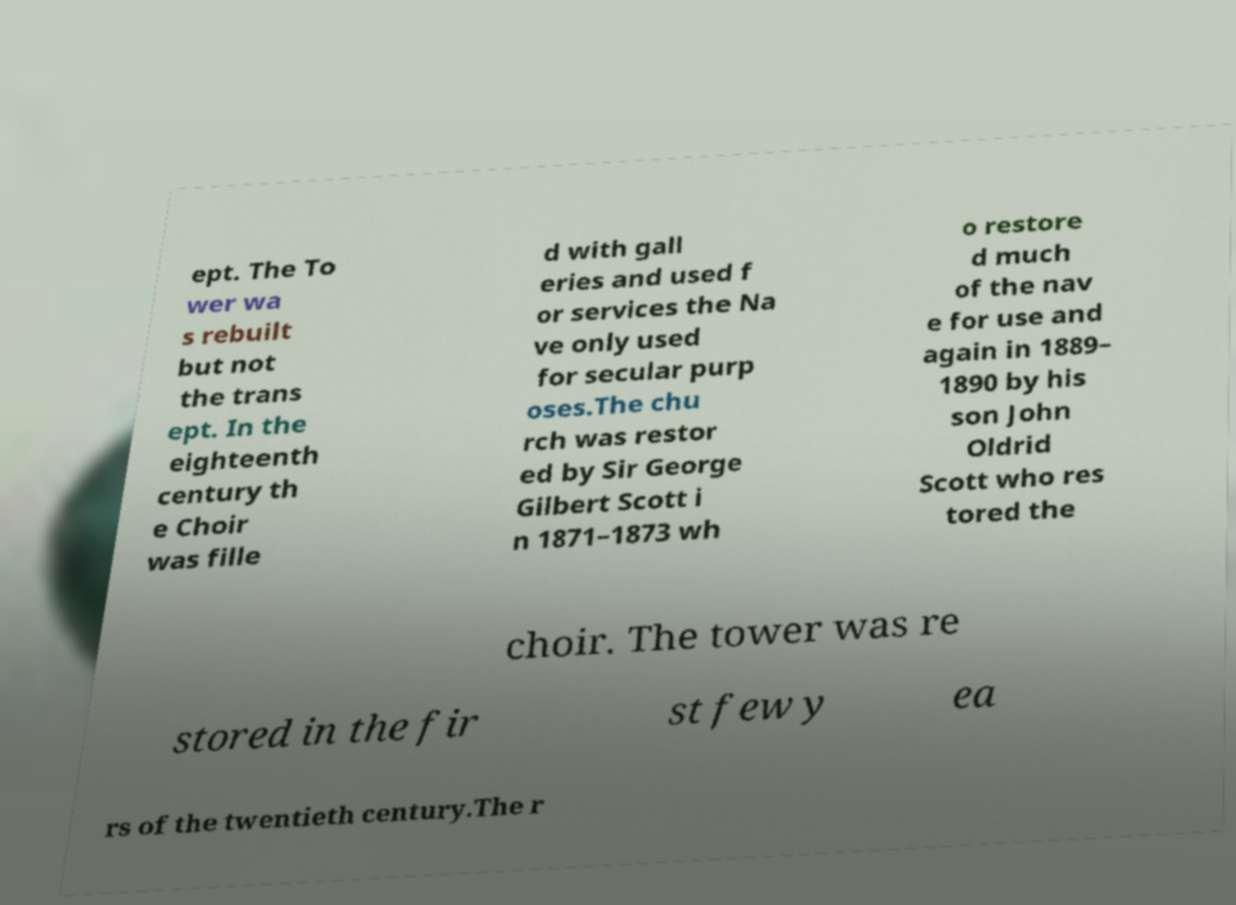Could you extract and type out the text from this image? ept. The To wer wa s rebuilt but not the trans ept. In the eighteenth century th e Choir was fille d with gall eries and used f or services the Na ve only used for secular purp oses.The chu rch was restor ed by Sir George Gilbert Scott i n 1871–1873 wh o restore d much of the nav e for use and again in 1889– 1890 by his son John Oldrid Scott who res tored the choir. The tower was re stored in the fir st few y ea rs of the twentieth century.The r 